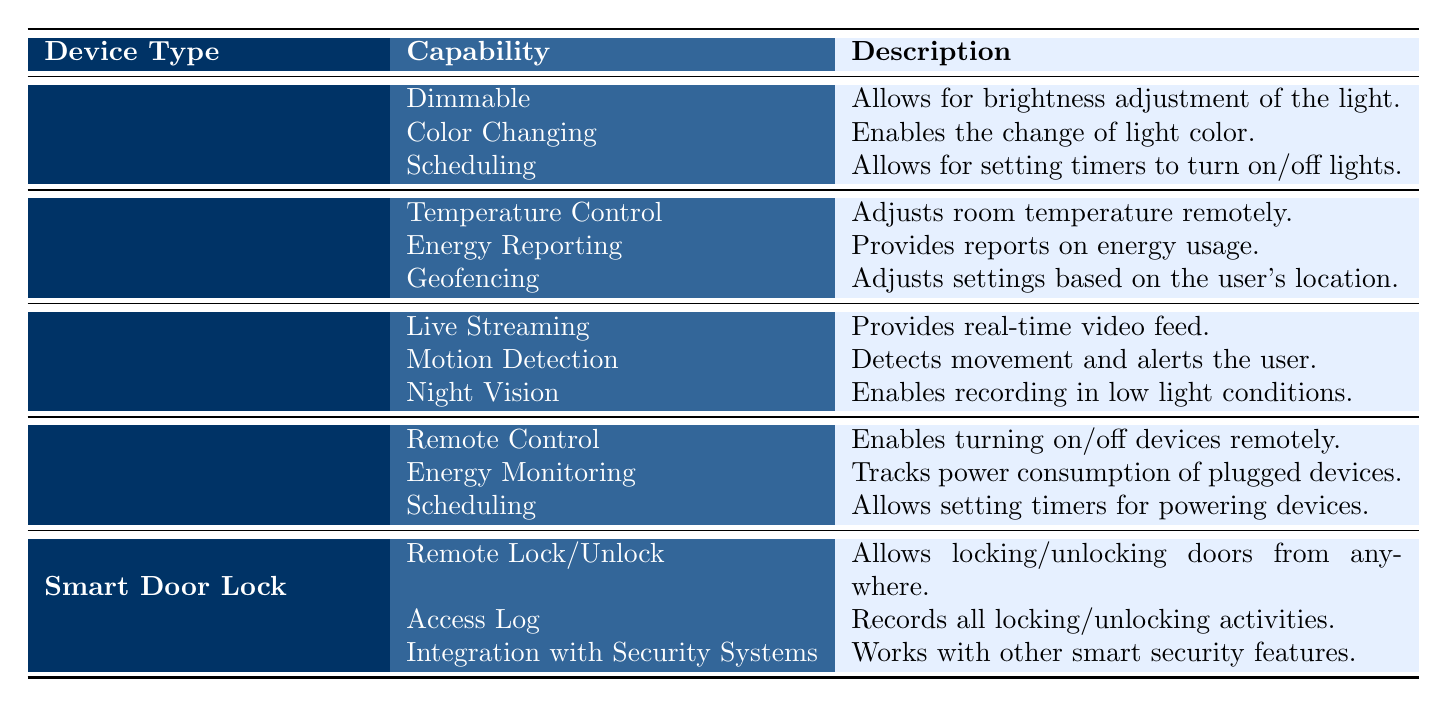What are the capabilities of Smart Lighting? The table lists three capabilities under Smart Lighting: Dimmable, Color Changing, and Scheduling. These can be directly found in the first row under the column "Device Type" for Smart Lighting and the corresponding capabilities listed in the "Capability" column.
Answer: Dimmable, Color Changing, Scheduling Does Smart Thermostat have the capability for Energy Reporting? The table indicates that Energy Reporting is a capability listed under Smart Thermostat. This can be directly checked by locating the Smart Thermostat entry and reading the capabilities listed.
Answer: Yes How many capabilities does Smart Security Camera have? By reviewing the table, Smart Security Camera is associated with three capabilities: Live Streaming, Motion Detection, and Night Vision. The count of capabilities can be obtained by reading through the entries for this device type.
Answer: 3 Is there a capability called Remote Control in Smart Plug? In the table, under Smart Plug, Remote Control is indeed listed as a capability. This can be verified by locating Smart Plug in the first column and checking its corresponding capabilities.
Answer: Yes What is the primary function of the capability named Night Vision? The Night Vision capability allows for recording in low light conditions under Smart Security Camera. This description can be found in the table under the capability's description column.
Answer: Enables recording in low light conditions Which device type has the capability to integrate with security systems? The Smart Door Lock has the capability listed as "Integration with Security Systems." This can be determined by looking at the corresponding row for Smart Door Lock and reading the capabilities in the table.
Answer: Smart Door Lock If I want to schedule my Smart Lighting to turn on, which capabilities will help me? The Scheduling capability is available under Smart Lighting, which specifically allows for setting timers to turn on/off lights. Hence, Scheduling is the capability to use.
Answer: Scheduling How many total capabilities are listed for all the device types combined? By examining the table, each of the five device types has three capabilities listed. Therefore, the total is 5 device types multiplied by 3 capabilities each, resulting in 15 capabilities in total.
Answer: 15 Are there any capabilities that overlap between Smart Plug and Smart Lighting? Yes, both Smart Plug and Smart Lighting have the Scheduling capability. This can be confirmed by checking the capabilities listed under each device type.
Answer: Yes 